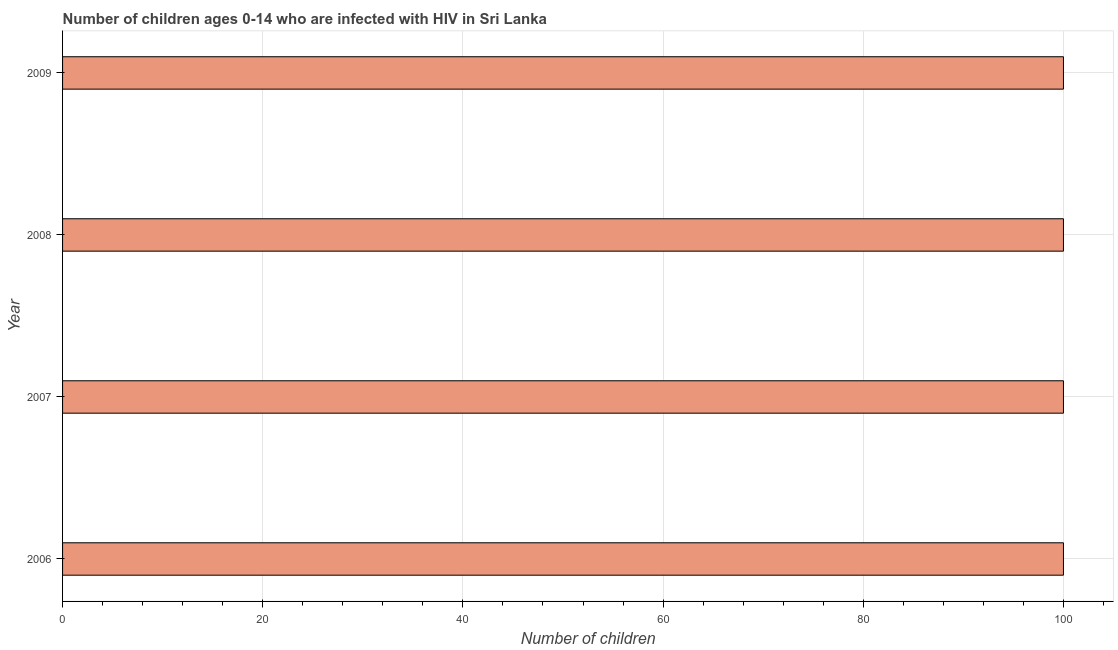What is the title of the graph?
Ensure brevity in your answer.  Number of children ages 0-14 who are infected with HIV in Sri Lanka. What is the label or title of the X-axis?
Make the answer very short. Number of children. What is the label or title of the Y-axis?
Offer a very short reply. Year. Across all years, what is the maximum number of children living with hiv?
Provide a succinct answer. 100. Across all years, what is the minimum number of children living with hiv?
Your answer should be compact. 100. In which year was the number of children living with hiv maximum?
Your response must be concise. 2006. In which year was the number of children living with hiv minimum?
Your answer should be compact. 2006. What is the sum of the number of children living with hiv?
Provide a short and direct response. 400. What is the difference between the number of children living with hiv in 2006 and 2008?
Provide a short and direct response. 0. What is the difference between the highest and the second highest number of children living with hiv?
Offer a terse response. 0. Is the sum of the number of children living with hiv in 2006 and 2009 greater than the maximum number of children living with hiv across all years?
Your response must be concise. Yes. In how many years, is the number of children living with hiv greater than the average number of children living with hiv taken over all years?
Offer a terse response. 0. Are all the bars in the graph horizontal?
Your answer should be very brief. Yes. Are the values on the major ticks of X-axis written in scientific E-notation?
Your answer should be very brief. No. What is the Number of children of 2007?
Provide a short and direct response. 100. What is the Number of children of 2008?
Give a very brief answer. 100. What is the difference between the Number of children in 2006 and 2007?
Your response must be concise. 0. What is the difference between the Number of children in 2006 and 2008?
Your answer should be compact. 0. What is the difference between the Number of children in 2007 and 2009?
Your answer should be very brief. 0. What is the difference between the Number of children in 2008 and 2009?
Provide a succinct answer. 0. What is the ratio of the Number of children in 2006 to that in 2007?
Offer a very short reply. 1. What is the ratio of the Number of children in 2006 to that in 2008?
Your answer should be very brief. 1. What is the ratio of the Number of children in 2006 to that in 2009?
Your response must be concise. 1. What is the ratio of the Number of children in 2007 to that in 2009?
Offer a terse response. 1. What is the ratio of the Number of children in 2008 to that in 2009?
Provide a short and direct response. 1. 